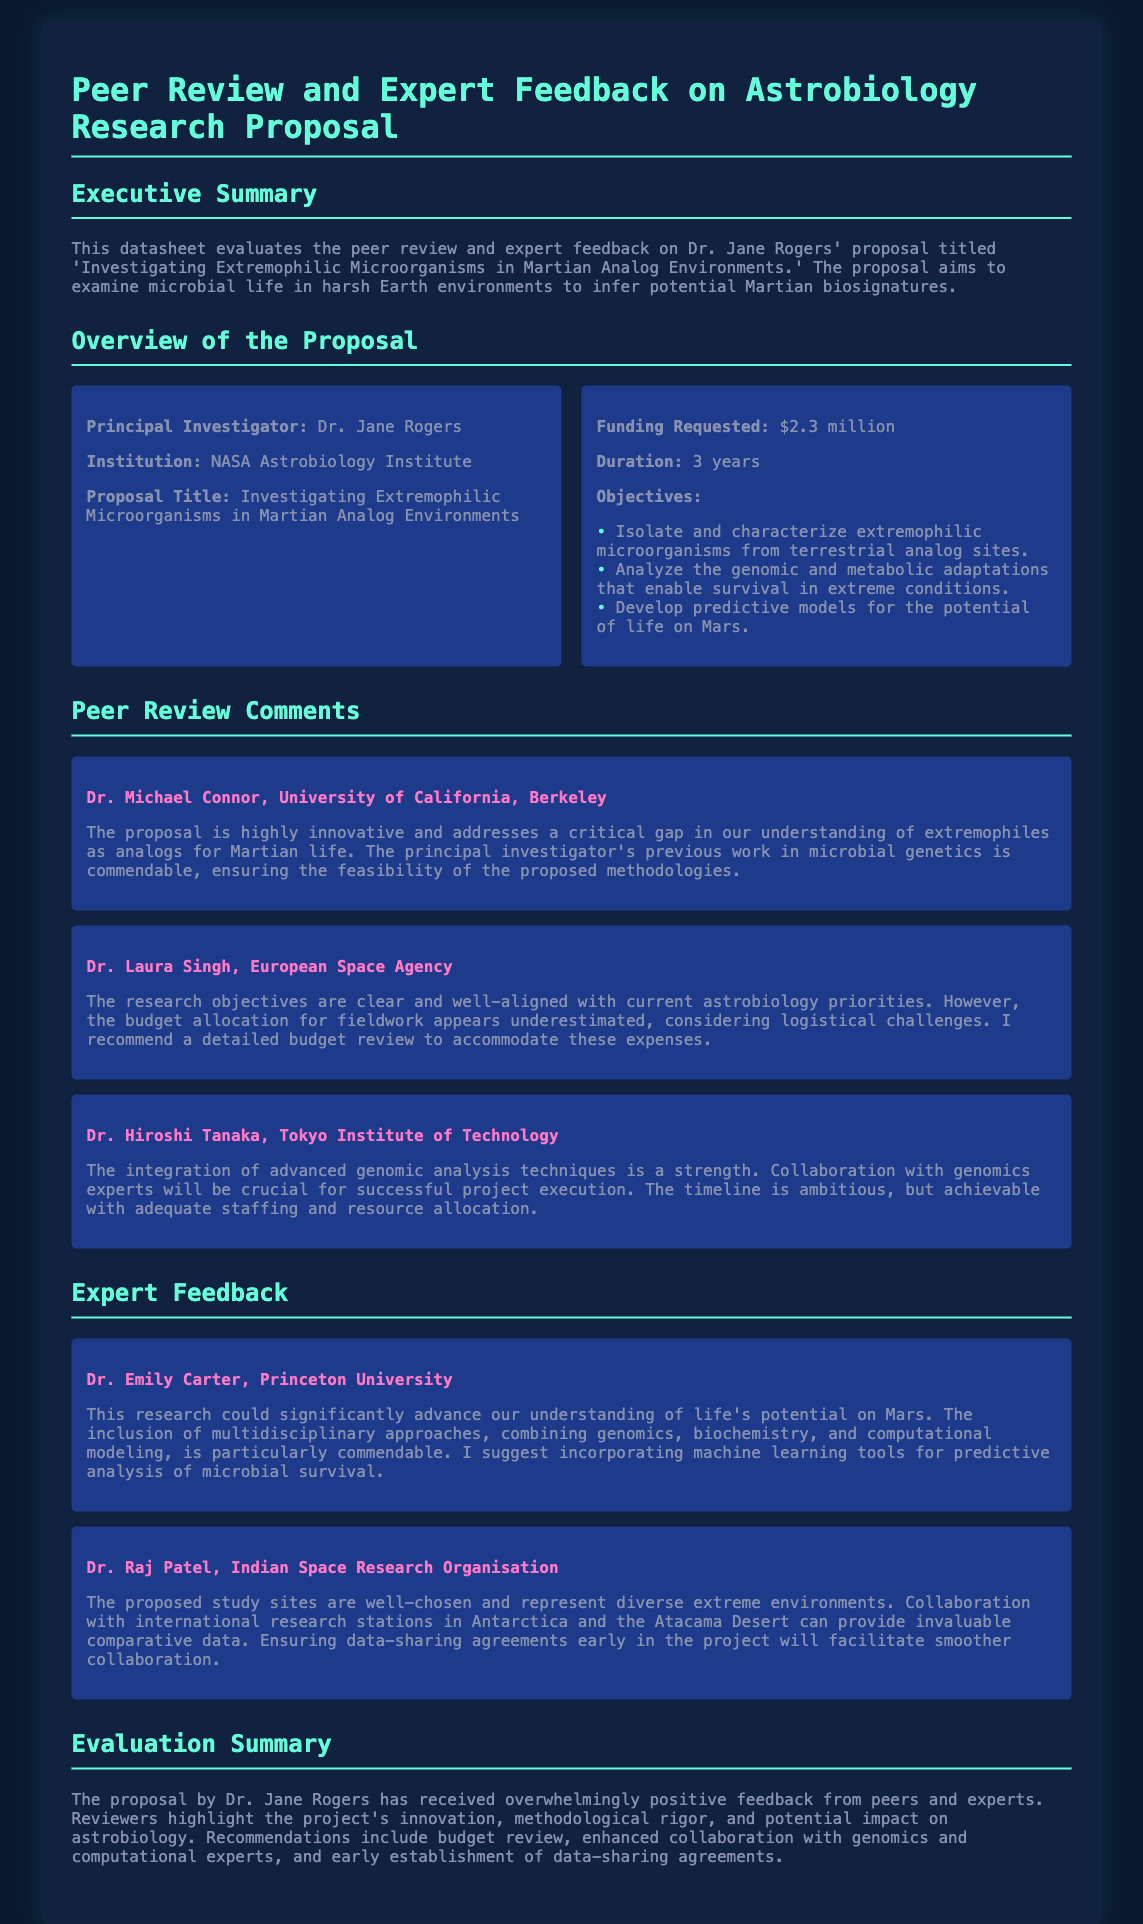What is the title of the proposal? The title is provided in the overview section of the document: 'Investigating Extremophilic Microorganisms in Martian Analog Environments.'
Answer: Investigating Extremophilic Microorganisms in Martian Analog Environments Who is the Principal Investigator? The Principal Investigator is mentioned in the overview section of the document as Dr. Jane Rogers.
Answer: Dr. Jane Rogers How much funding is requested? The funding requested is specified in the overview section: $2.3 million.
Answer: $2.3 million What duration is proposed for the research? The duration of the research is stated in the overview section as 3 years.
Answer: 3 years Which reviewer highlighted the importance of genomic analysis techniques? The reviewer who emphasized this is Dr. Hiroshi Tanaka from the Tokyo Institute of Technology.
Answer: Dr. Hiroshi Tanaka What was suggested to enhance predictive analysis of microbial survival? The suggestion is found in the expert feedback section, where Dr. Emily Carter mentions incorporating machine learning tools.
Answer: Incorporating machine learning tools What are the recommended actions for budget allocation? The specific recommendation from Dr. Laura Singh is a detailed budget review to accommodate fieldwork expenses.
Answer: Detailed budget review What collaborative opportunities were mentioned by Dr. Raj Patel? Dr. Raj Patel suggested collaboration with international research stations in Antarctica and the Atacama Desert.
Answer: International research stations in Antarctica and the Atacama Desert 